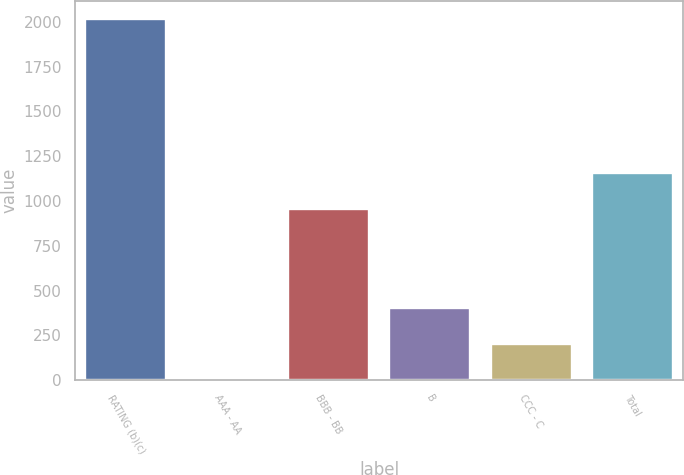<chart> <loc_0><loc_0><loc_500><loc_500><bar_chart><fcel>RATING (b)(c)<fcel>AAA - AA<fcel>BBB - BB<fcel>B<fcel>CCC - C<fcel>Total<nl><fcel>2014<fcel>1<fcel>956<fcel>403.6<fcel>202.3<fcel>1157.3<nl></chart> 